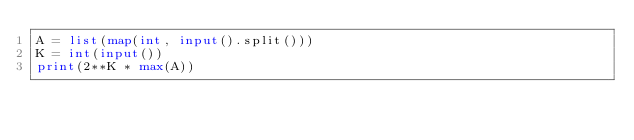Convert code to text. <code><loc_0><loc_0><loc_500><loc_500><_Python_>A = list(map(int, input().split()))
K = int(input())
print(2**K * max(A))</code> 